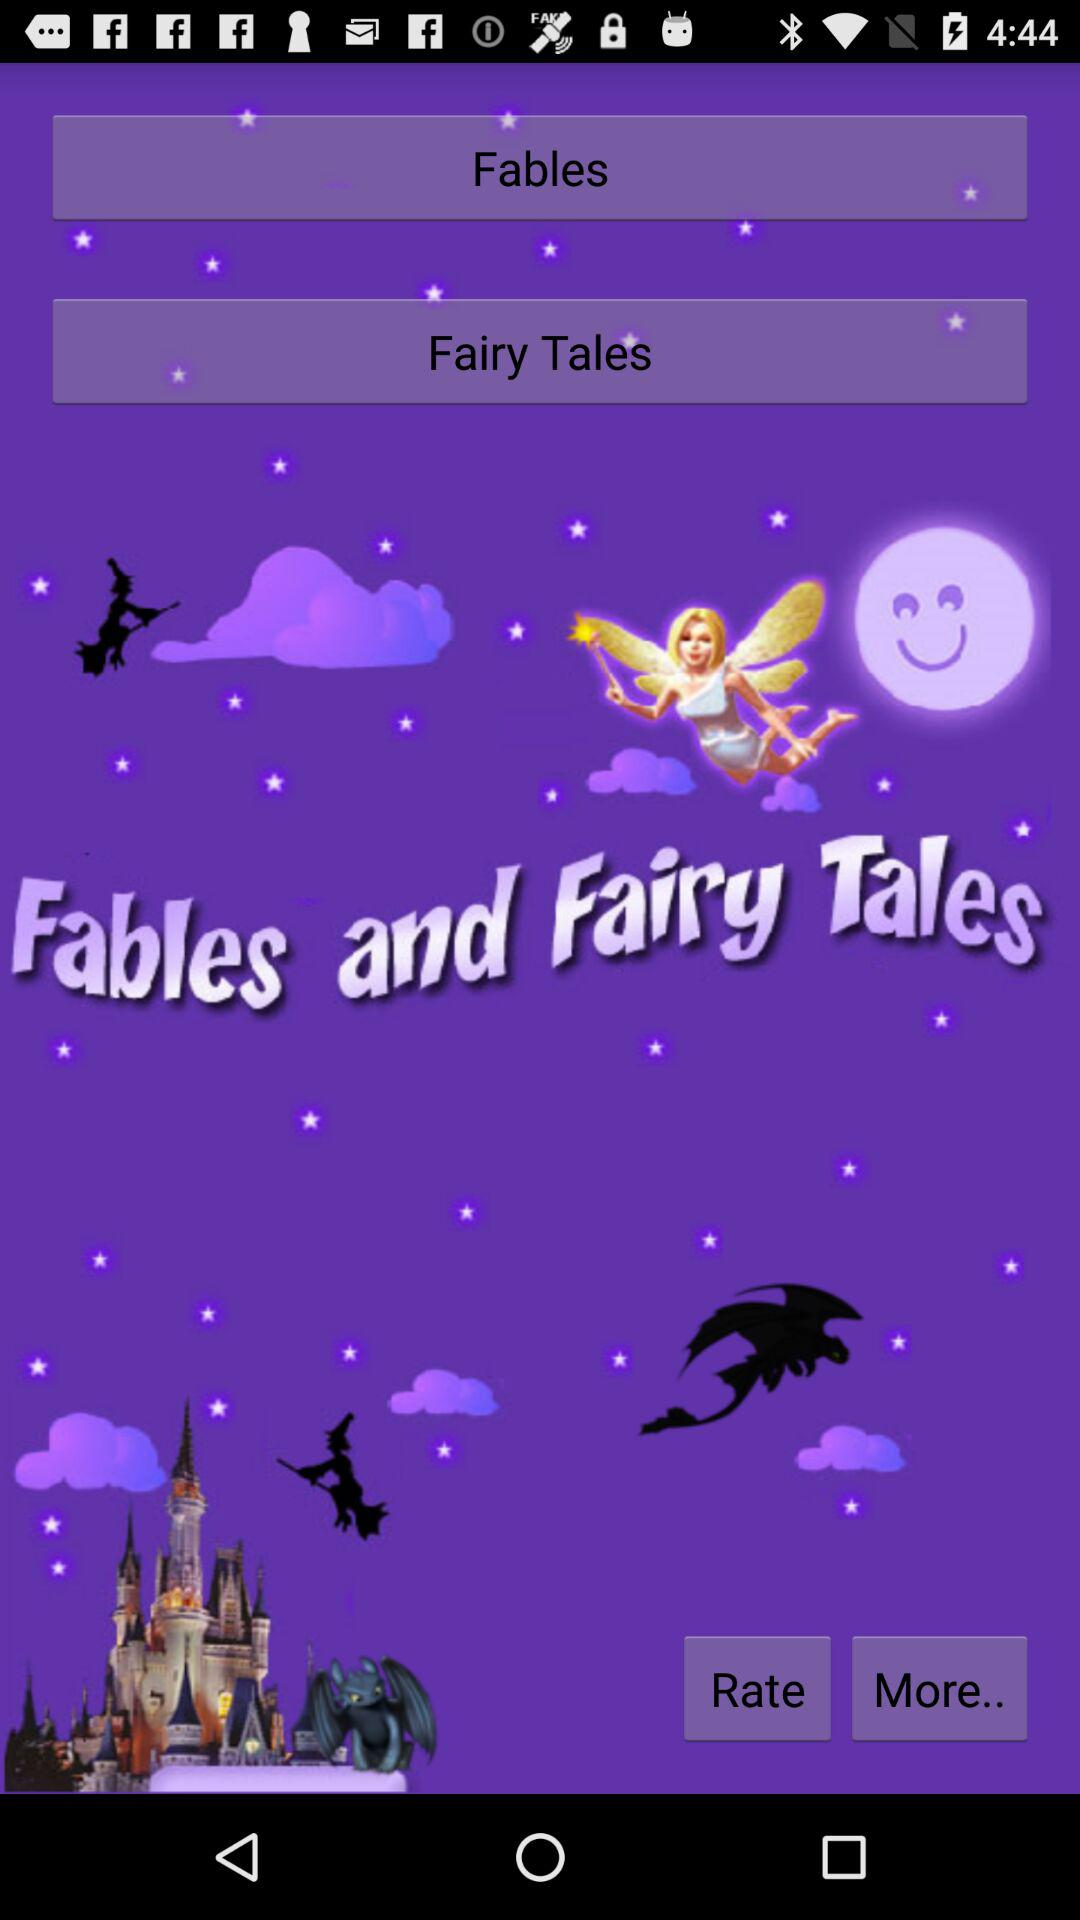What is the name of the application? The name of the application is "Fables and Fairy Tales". 